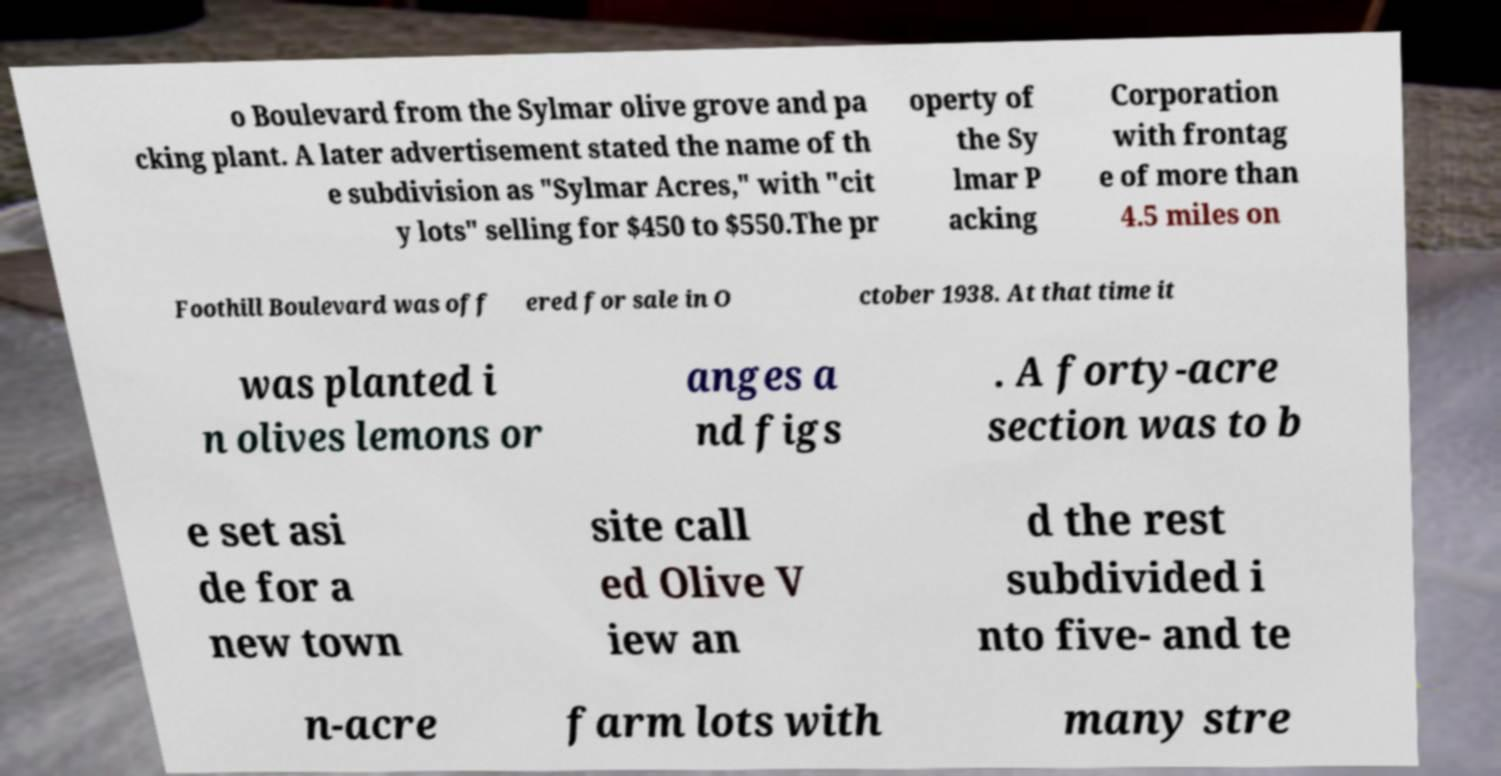Please identify and transcribe the text found in this image. o Boulevard from the Sylmar olive grove and pa cking plant. A later advertisement stated the name of th e subdivision as "Sylmar Acres," with "cit y lots" selling for $450 to $550.The pr operty of the Sy lmar P acking Corporation with frontag e of more than 4.5 miles on Foothill Boulevard was off ered for sale in O ctober 1938. At that time it was planted i n olives lemons or anges a nd figs . A forty-acre section was to b e set asi de for a new town site call ed Olive V iew an d the rest subdivided i nto five- and te n-acre farm lots with many stre 